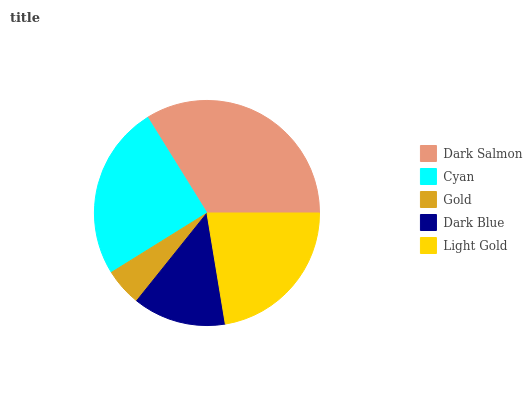Is Gold the minimum?
Answer yes or no. Yes. Is Dark Salmon the maximum?
Answer yes or no. Yes. Is Cyan the minimum?
Answer yes or no. No. Is Cyan the maximum?
Answer yes or no. No. Is Dark Salmon greater than Cyan?
Answer yes or no. Yes. Is Cyan less than Dark Salmon?
Answer yes or no. Yes. Is Cyan greater than Dark Salmon?
Answer yes or no. No. Is Dark Salmon less than Cyan?
Answer yes or no. No. Is Light Gold the high median?
Answer yes or no. Yes. Is Light Gold the low median?
Answer yes or no. Yes. Is Gold the high median?
Answer yes or no. No. Is Dark Salmon the low median?
Answer yes or no. No. 